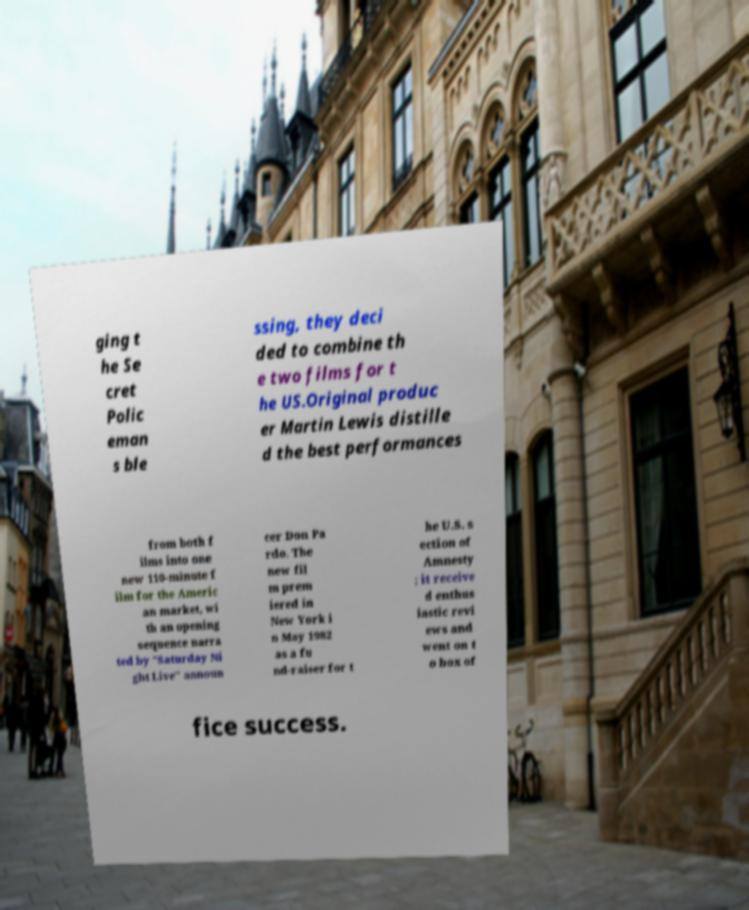For documentation purposes, I need the text within this image transcribed. Could you provide that? ging t he Se cret Polic eman s ble ssing, they deci ded to combine th e two films for t he US.Original produc er Martin Lewis distille d the best performances from both f ilms into one new 110-minute f ilm for the Americ an market, wi th an opening sequence narra ted by "Saturday Ni ght Live" announ cer Don Pa rdo. The new fil m prem iered in New York i n May 1982 as a fu nd-raiser for t he U.S. s ection of Amnesty ; it receive d enthus iastic revi ews and went on t o box of fice success. 